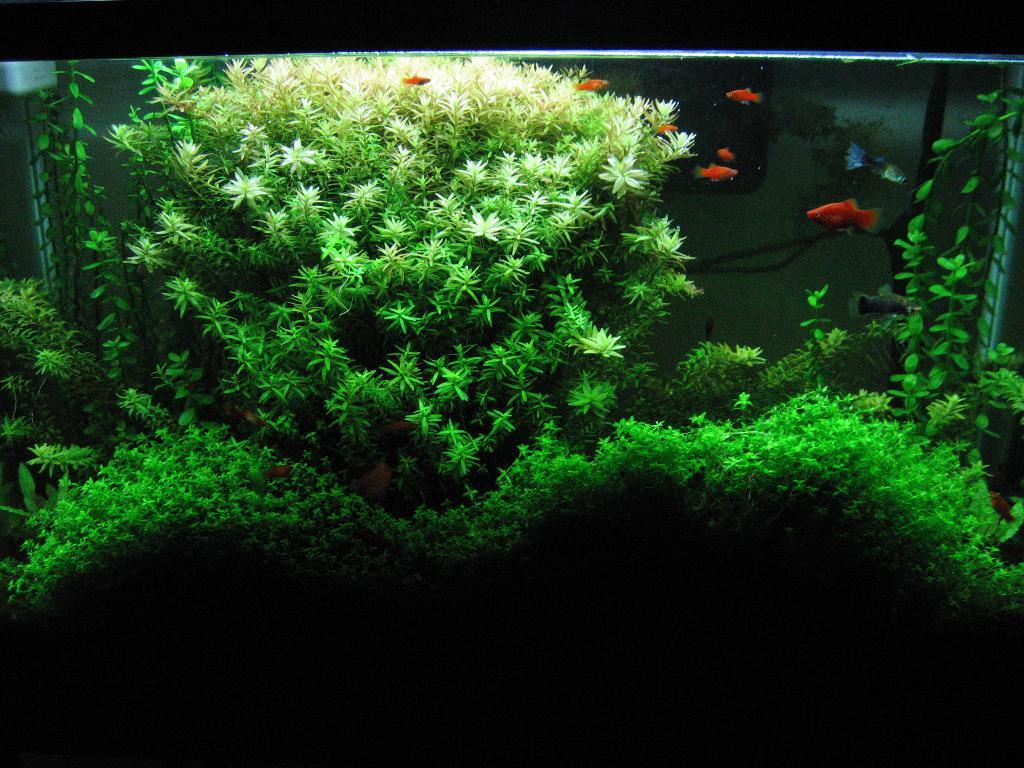What is the main subject in the center of the image? There is an aquarium in the center of the image. What can be found inside the aquarium? There are plants in the aquarium. Where are the fishes located in relation to the aquarium? The fishes are on the right side of the aquarium. How many houses can be seen in the wilderness on the left side of the image? There are no houses or wilderness present in the image; it features an aquarium with plants and fishes. 